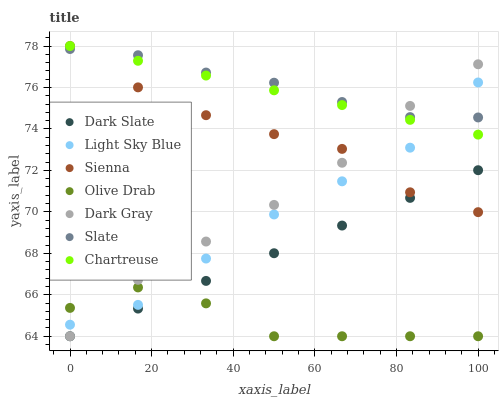Does Olive Drab have the minimum area under the curve?
Answer yes or no. Yes. Does Slate have the maximum area under the curve?
Answer yes or no. Yes. Does Sienna have the minimum area under the curve?
Answer yes or no. No. Does Sienna have the maximum area under the curve?
Answer yes or no. No. Is Chartreuse the smoothest?
Answer yes or no. Yes. Is Olive Drab the roughest?
Answer yes or no. Yes. Is Slate the smoothest?
Answer yes or no. No. Is Slate the roughest?
Answer yes or no. No. Does Dark Gray have the lowest value?
Answer yes or no. Yes. Does Sienna have the lowest value?
Answer yes or no. No. Does Chartreuse have the highest value?
Answer yes or no. Yes. Does Slate have the highest value?
Answer yes or no. No. Is Olive Drab less than Sienna?
Answer yes or no. Yes. Is Chartreuse greater than Dark Slate?
Answer yes or no. Yes. Does Dark Gray intersect Light Sky Blue?
Answer yes or no. Yes. Is Dark Gray less than Light Sky Blue?
Answer yes or no. No. Is Dark Gray greater than Light Sky Blue?
Answer yes or no. No. Does Olive Drab intersect Sienna?
Answer yes or no. No. 